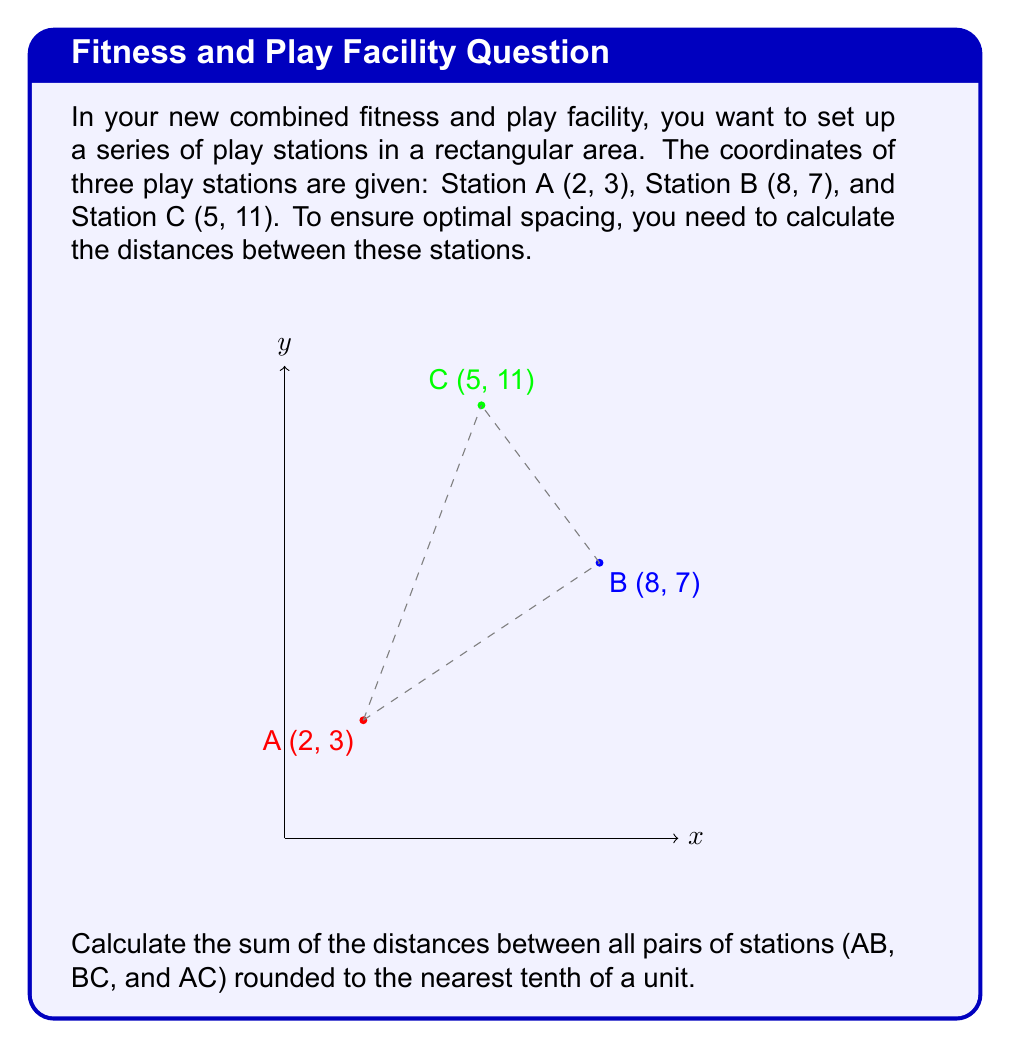What is the answer to this math problem? To solve this problem, we'll use the distance formula between two points in a coordinate system:

$$d = \sqrt{(x_2-x_1)^2 + (y_2-y_1)^2}$$

Let's calculate the distance for each pair of stations:

1. Distance AB:
   $$d_{AB} = \sqrt{(8-2)^2 + (7-3)^2} = \sqrt{6^2 + 4^2} = \sqrt{36 + 16} = \sqrt{52} \approx 7.21$$

2. Distance BC:
   $$d_{BC} = \sqrt{(5-8)^2 + (11-7)^2} = \sqrt{(-3)^2 + 4^2} = \sqrt{9 + 16} = \sqrt{25} = 5$$

3. Distance AC:
   $$d_{AC} = \sqrt{(5-2)^2 + (11-3)^2} = \sqrt{3^2 + 8^2} = \sqrt{9 + 64} = \sqrt{73} \approx 8.54$$

Now, we sum up all the distances:

$$\text{Total distance} = d_{AB} + d_{BC} + d_{AC} \approx 7.21 + 5 + 8.54 = 20.75$$

Rounding to the nearest tenth, we get 20.8 units.
Answer: 20.8 units 